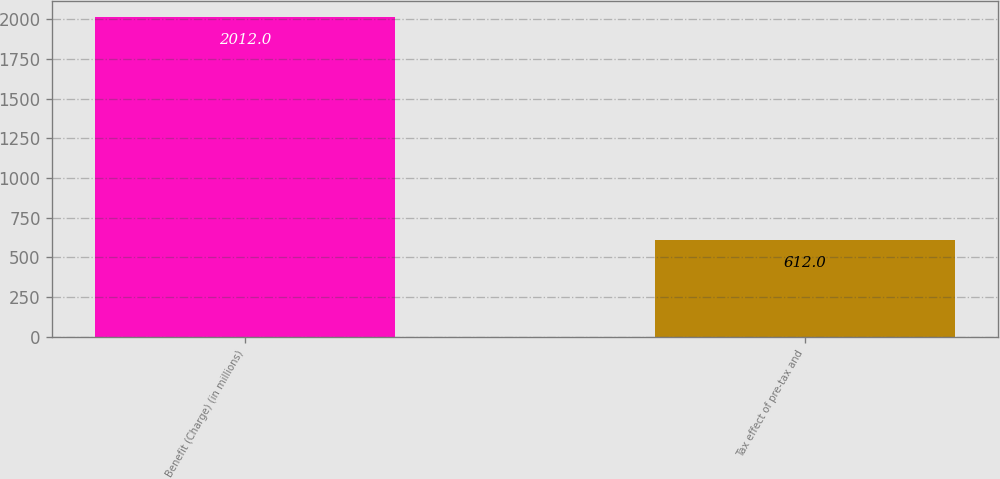<chart> <loc_0><loc_0><loc_500><loc_500><bar_chart><fcel>Benefit (Charge) (in millions)<fcel>Tax effect of pre-tax and<nl><fcel>2012<fcel>612<nl></chart> 